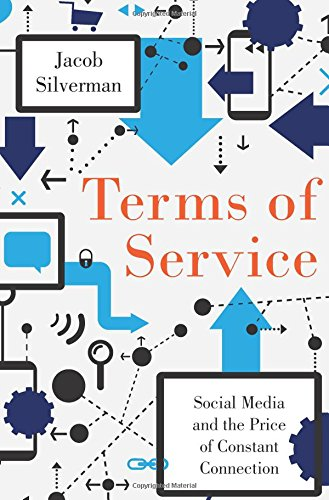Is this book related to Computers & Technology? Yes, this book directly relates to Computers & Technology as it examines the profound influence of social media platforms and technology on personal and social behavior. 